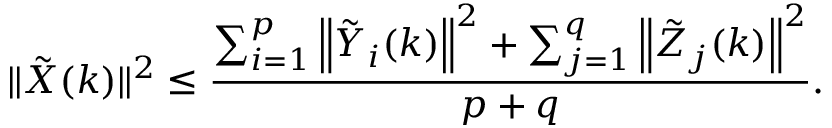<formula> <loc_0><loc_0><loc_500><loc_500>\| \tilde { X } ( k ) \| ^ { 2 } \leq \frac { \sum _ { i = 1 } ^ { p } \left \| \tilde { Y } _ { i } ( k ) \right \| ^ { 2 } + \sum _ { j = 1 } ^ { q } \left \| \tilde { Z } _ { j } ( k ) \right \| ^ { 2 } } { p + q } .</formula> 